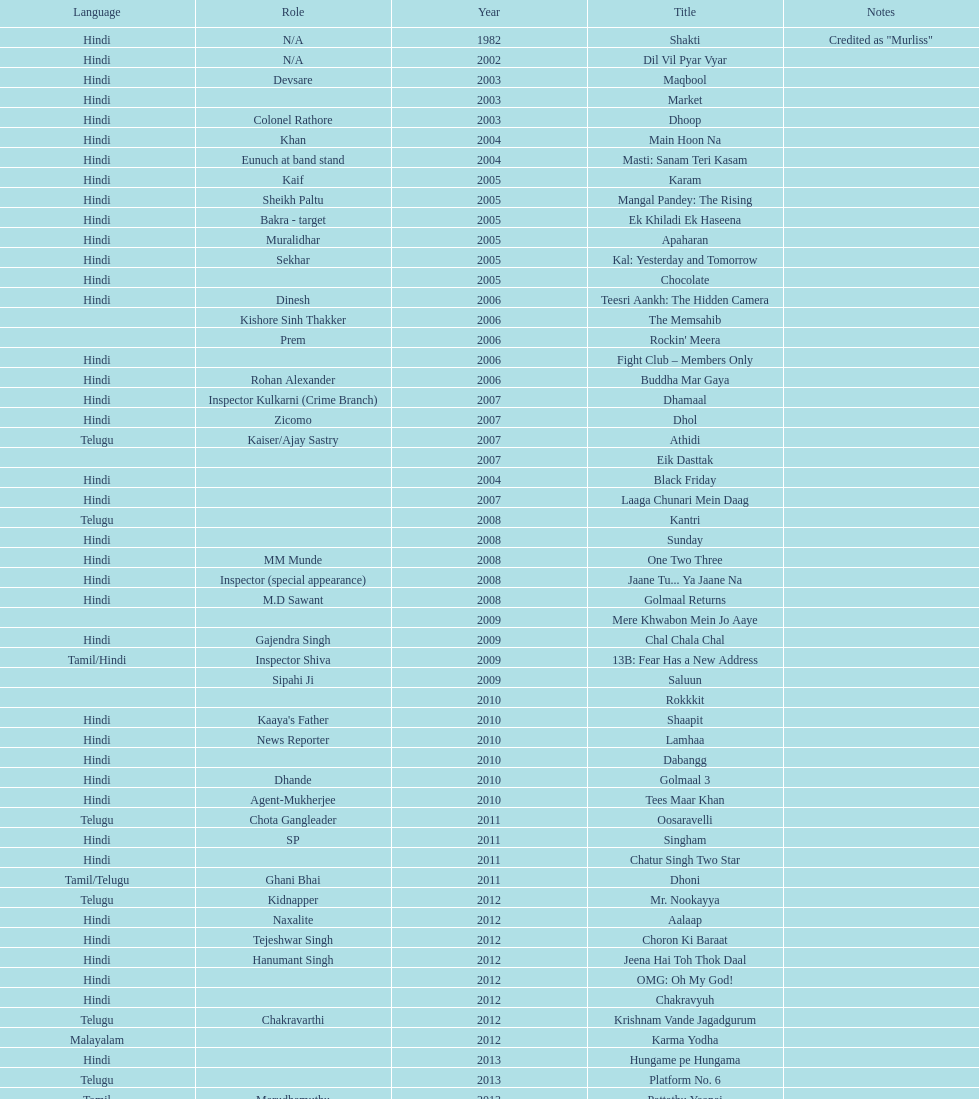What title is before dhol in 2007? Dhamaal. Can you parse all the data within this table? {'header': ['Language', 'Role', 'Year', 'Title', 'Notes'], 'rows': [['Hindi', 'N/A', '1982', 'Shakti', 'Credited as "Murliss"'], ['Hindi', 'N/A', '2002', 'Dil Vil Pyar Vyar', ''], ['Hindi', 'Devsare', '2003', 'Maqbool', ''], ['Hindi', '', '2003', 'Market', ''], ['Hindi', 'Colonel Rathore', '2003', 'Dhoop', ''], ['Hindi', 'Khan', '2004', 'Main Hoon Na', ''], ['Hindi', 'Eunuch at band stand', '2004', 'Masti: Sanam Teri Kasam', ''], ['Hindi', 'Kaif', '2005', 'Karam', ''], ['Hindi', 'Sheikh Paltu', '2005', 'Mangal Pandey: The Rising', ''], ['Hindi', 'Bakra - target', '2005', 'Ek Khiladi Ek Haseena', ''], ['Hindi', 'Muralidhar', '2005', 'Apaharan', ''], ['Hindi', 'Sekhar', '2005', 'Kal: Yesterday and Tomorrow', ''], ['Hindi', '', '2005', 'Chocolate', ''], ['Hindi', 'Dinesh', '2006', 'Teesri Aankh: The Hidden Camera', ''], ['', 'Kishore Sinh Thakker', '2006', 'The Memsahib', ''], ['', 'Prem', '2006', "Rockin' Meera", ''], ['Hindi', '', '2006', 'Fight Club – Members Only', ''], ['Hindi', 'Rohan Alexander', '2006', 'Buddha Mar Gaya', ''], ['Hindi', 'Inspector Kulkarni (Crime Branch)', '2007', 'Dhamaal', ''], ['Hindi', 'Zicomo', '2007', 'Dhol', ''], ['Telugu', 'Kaiser/Ajay Sastry', '2007', 'Athidi', ''], ['', '', '2007', 'Eik Dasttak', ''], ['Hindi', '', '2004', 'Black Friday', ''], ['Hindi', '', '2007', 'Laaga Chunari Mein Daag', ''], ['Telugu', '', '2008', 'Kantri', ''], ['Hindi', '', '2008', 'Sunday', ''], ['Hindi', 'MM Munde', '2008', 'One Two Three', ''], ['Hindi', 'Inspector (special appearance)', '2008', 'Jaane Tu... Ya Jaane Na', ''], ['Hindi', 'M.D Sawant', '2008', 'Golmaal Returns', ''], ['', '', '2009', 'Mere Khwabon Mein Jo Aaye', ''], ['Hindi', 'Gajendra Singh', '2009', 'Chal Chala Chal', ''], ['Tamil/Hindi', 'Inspector Shiva', '2009', '13B: Fear Has a New Address', ''], ['', 'Sipahi Ji', '2009', 'Saluun', ''], ['', '', '2010', 'Rokkkit', ''], ['Hindi', "Kaaya's Father", '2010', 'Shaapit', ''], ['Hindi', 'News Reporter', '2010', 'Lamhaa', ''], ['Hindi', '', '2010', 'Dabangg', ''], ['Hindi', 'Dhande', '2010', 'Golmaal 3', ''], ['Hindi', 'Agent-Mukherjee', '2010', 'Tees Maar Khan', ''], ['Telugu', 'Chota Gangleader', '2011', 'Oosaravelli', ''], ['Hindi', 'SP', '2011', 'Singham', ''], ['Hindi', '', '2011', 'Chatur Singh Two Star', ''], ['Tamil/Telugu', 'Ghani Bhai', '2011', 'Dhoni', ''], ['Telugu', 'Kidnapper', '2012', 'Mr. Nookayya', ''], ['Hindi', 'Naxalite', '2012', 'Aalaap', ''], ['Hindi', 'Tejeshwar Singh', '2012', 'Choron Ki Baraat', ''], ['Hindi', 'Hanumant Singh', '2012', 'Jeena Hai Toh Thok Daal', ''], ['Hindi', '', '2012', 'OMG: Oh My God!', ''], ['Hindi', '', '2012', 'Chakravyuh', ''], ['Telugu', 'Chakravarthi', '2012', 'Krishnam Vande Jagadgurum', ''], ['Malayalam', '', '2012', 'Karma Yodha', ''], ['Hindi', '', '2013', 'Hungame pe Hungama', ''], ['Telugu', '', '2013', 'Platform No. 6', ''], ['Tamil', 'Marudhamuthu', '2013', 'Pattathu Yaanai', ''], ['Hindi', '', '2013', 'Zindagi 50-50', ''], ['Telugu', 'Durani', '2013', 'Yevadu', ''], ['Telugu', '', '2013', 'Karmachari', '']]} 